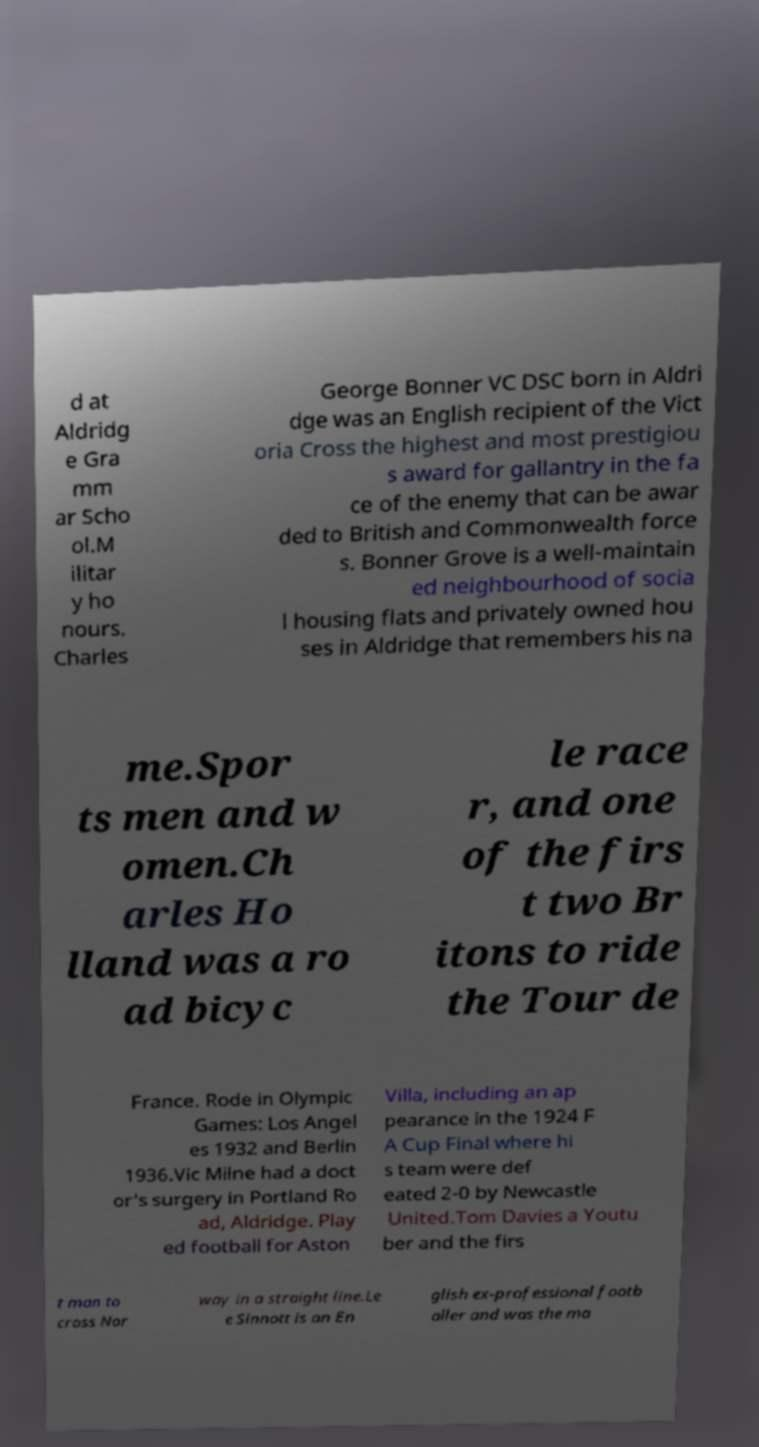Can you read and provide the text displayed in the image?This photo seems to have some interesting text. Can you extract and type it out for me? d at Aldridg e Gra mm ar Scho ol.M ilitar y ho nours. Charles George Bonner VC DSC born in Aldri dge was an English recipient of the Vict oria Cross the highest and most prestigiou s award for gallantry in the fa ce of the enemy that can be awar ded to British and Commonwealth force s. Bonner Grove is a well-maintain ed neighbourhood of socia l housing flats and privately owned hou ses in Aldridge that remembers his na me.Spor ts men and w omen.Ch arles Ho lland was a ro ad bicyc le race r, and one of the firs t two Br itons to ride the Tour de France. Rode in Olympic Games: Los Angel es 1932 and Berlin 1936.Vic Milne had a doct or's surgery in Portland Ro ad, Aldridge. Play ed football for Aston Villa, including an ap pearance in the 1924 F A Cup Final where hi s team were def eated 2-0 by Newcastle United.Tom Davies a Youtu ber and the firs t man to cross Nor way in a straight line.Le e Sinnott is an En glish ex-professional footb aller and was the ma 